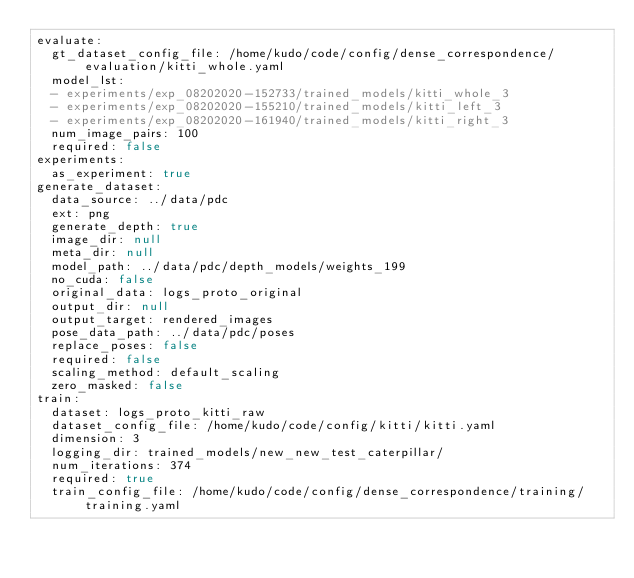Convert code to text. <code><loc_0><loc_0><loc_500><loc_500><_YAML_>evaluate:
  gt_dataset_config_file: /home/kudo/code/config/dense_correspondence/evaluation/kitti_whole.yaml
  model_lst:
  - experiments/exp_08202020-152733/trained_models/kitti_whole_3
  - experiments/exp_08202020-155210/trained_models/kitti_left_3
  - experiments/exp_08202020-161940/trained_models/kitti_right_3
  num_image_pairs: 100
  required: false
experiments:
  as_experiment: true
generate_dataset:
  data_source: ../data/pdc
  ext: png
  generate_depth: true
  image_dir: null
  meta_dir: null
  model_path: ../data/pdc/depth_models/weights_199
  no_cuda: false
  original_data: logs_proto_original
  output_dir: null
  output_target: rendered_images
  pose_data_path: ../data/pdc/poses
  replace_poses: false
  required: false
  scaling_method: default_scaling
  zero_masked: false
train:
  dataset: logs_proto_kitti_raw
  dataset_config_file: /home/kudo/code/config/kitti/kitti.yaml
  dimension: 3
  logging_dir: trained_models/new_new_test_caterpillar/
  num_iterations: 374
  required: true
  train_config_file: /home/kudo/code/config/dense_correspondence/training/training.yaml
</code> 